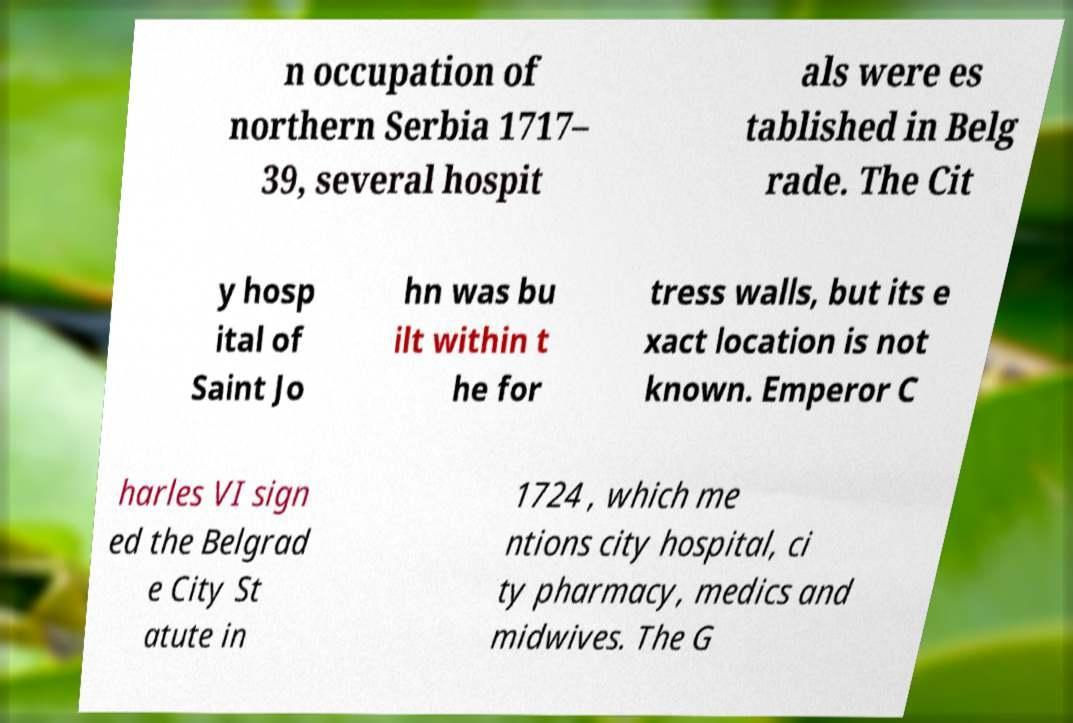Can you accurately transcribe the text from the provided image for me? n occupation of northern Serbia 1717– 39, several hospit als were es tablished in Belg rade. The Cit y hosp ital of Saint Jo hn was bu ilt within t he for tress walls, but its e xact location is not known. Emperor C harles VI sign ed the Belgrad e City St atute in 1724 , which me ntions city hospital, ci ty pharmacy, medics and midwives. The G 